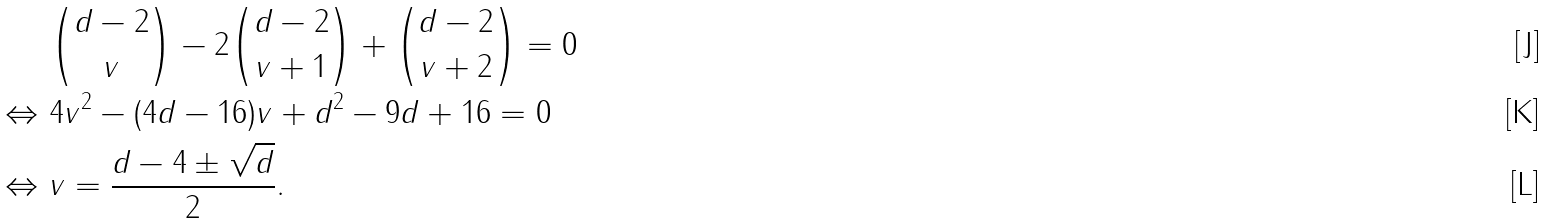<formula> <loc_0><loc_0><loc_500><loc_500>& \binom { d - 2 } { v } - 2 \binom { d - 2 } { v + 1 } + \binom { d - 2 } { v + 2 } = 0 \\ \Leftrightarrow \ & 4 v ^ { 2 } - ( 4 d - 1 6 ) v + d ^ { 2 } - 9 d + 1 6 = 0 \\ \Leftrightarrow \ & v = \frac { d - 4 \pm \sqrt { d } } { 2 } .</formula> 